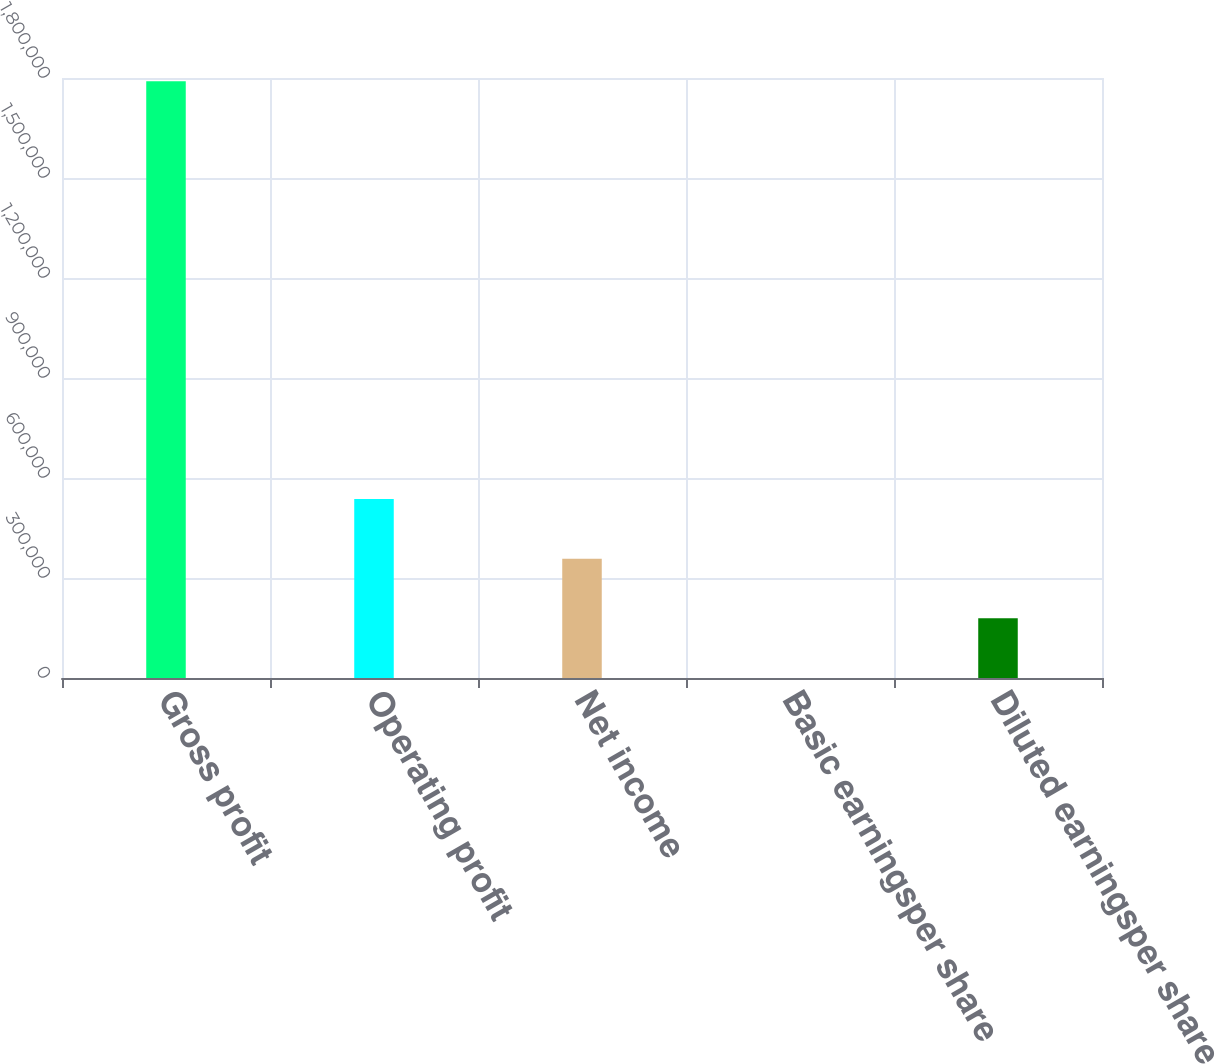<chart> <loc_0><loc_0><loc_500><loc_500><bar_chart><fcel>Gross profit<fcel>Operating profit<fcel>Net income<fcel>Basic earningsper share<fcel>Diluted earningsper share<nl><fcel>1.79052e+06<fcel>537157<fcel>358105<fcel>1.08<fcel>179053<nl></chart> 